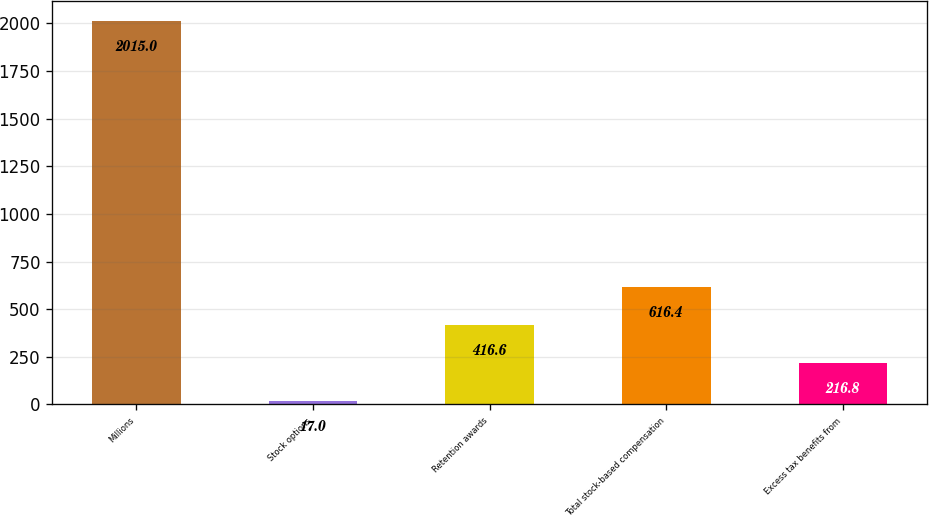<chart> <loc_0><loc_0><loc_500><loc_500><bar_chart><fcel>Millions<fcel>Stock options<fcel>Retention awards<fcel>Total stock-based compensation<fcel>Excess tax benefits from<nl><fcel>2015<fcel>17<fcel>416.6<fcel>616.4<fcel>216.8<nl></chart> 